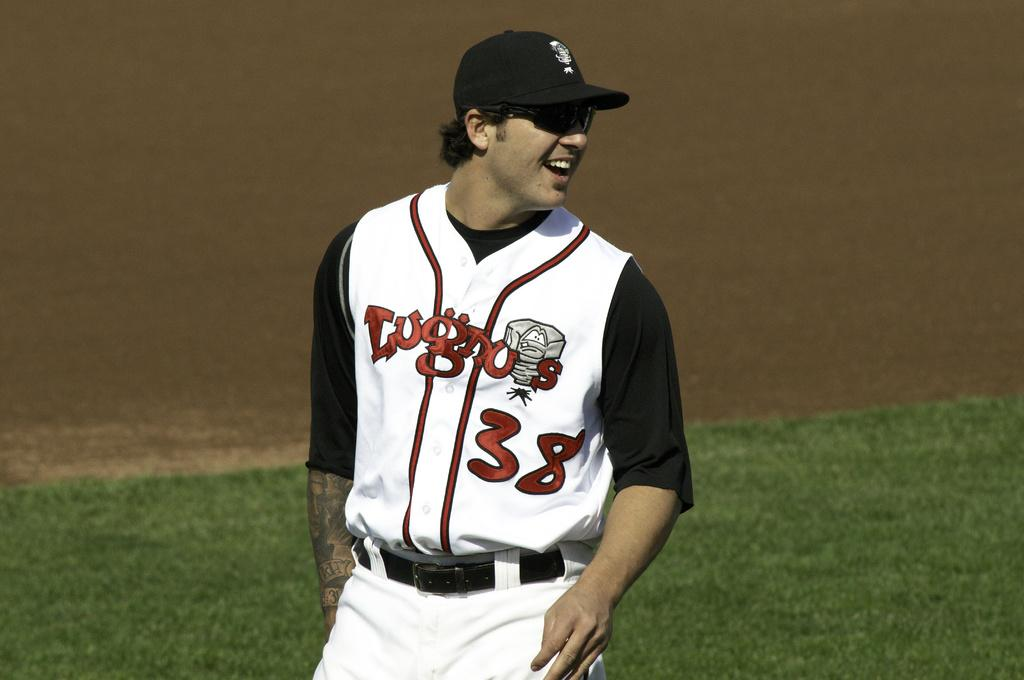<image>
Offer a succinct explanation of the picture presented. A Luginos baseball player wearing number 38 smiles after his teammate records an out 